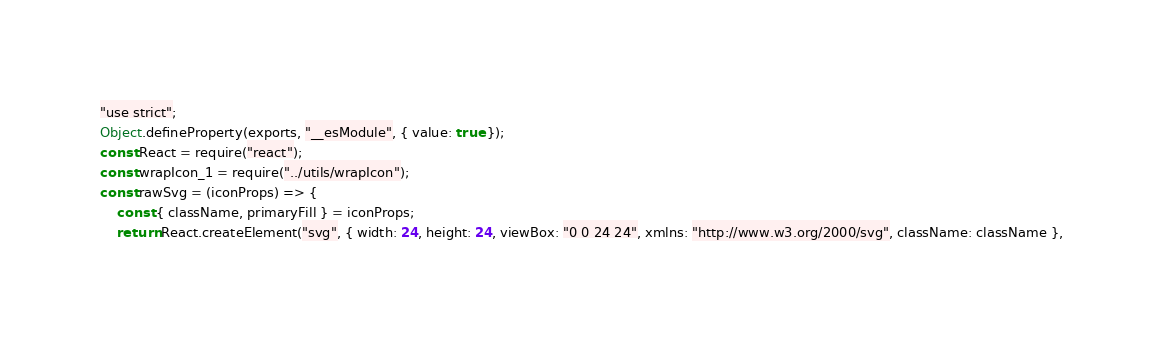Convert code to text. <code><loc_0><loc_0><loc_500><loc_500><_JavaScript_>"use strict";
Object.defineProperty(exports, "__esModule", { value: true });
const React = require("react");
const wrapIcon_1 = require("../utils/wrapIcon");
const rawSvg = (iconProps) => {
    const { className, primaryFill } = iconProps;
    return React.createElement("svg", { width: 24, height: 24, viewBox: "0 0 24 24", xmlns: "http://www.w3.org/2000/svg", className: className },</code> 